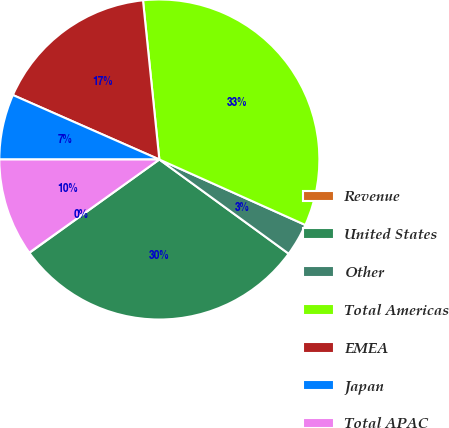Convert chart. <chart><loc_0><loc_0><loc_500><loc_500><pie_chart><fcel>Revenue<fcel>United States<fcel>Other<fcel>Total Americas<fcel>EMEA<fcel>Japan<fcel>Total APAC<nl><fcel>0.03%<fcel>30.06%<fcel>3.31%<fcel>33.34%<fcel>16.77%<fcel>6.6%<fcel>9.89%<nl></chart> 